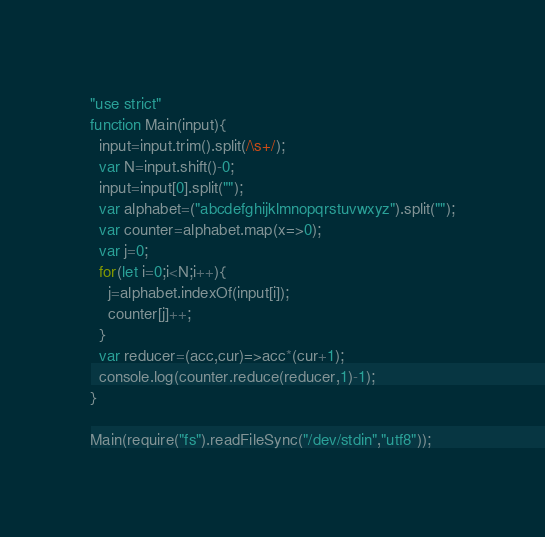<code> <loc_0><loc_0><loc_500><loc_500><_JavaScript_>"use strict"
function Main(input){
  input=input.trim().split(/\s+/);
  var N=input.shift()-0;
  input=input[0].split("");
  var alphabet=("abcdefghijklmnopqrstuvwxyz").split("");
  var counter=alphabet.map(x=>0);
  var j=0;
  for(let i=0;i<N;i++){
    j=alphabet.indexOf(input[i]);
    counter[j]++;
  }
  var reducer=(acc,cur)=>acc*(cur+1);
  console.log(counter.reduce(reducer,1)-1);
}

Main(require("fs").readFileSync("/dev/stdin","utf8"));</code> 